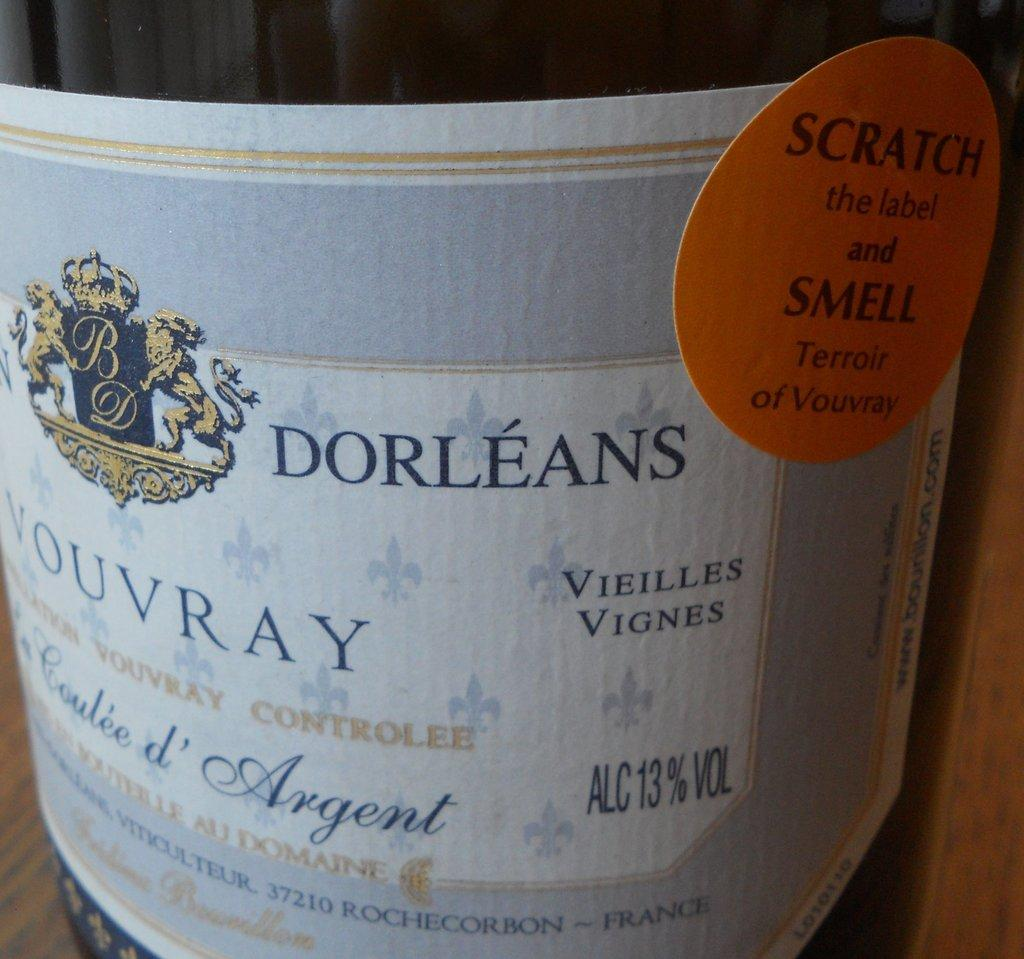Provide a one-sentence caption for the provided image. A orange sticker indicates that you can scratch it to smell the Terroir of Vouvray wine. 